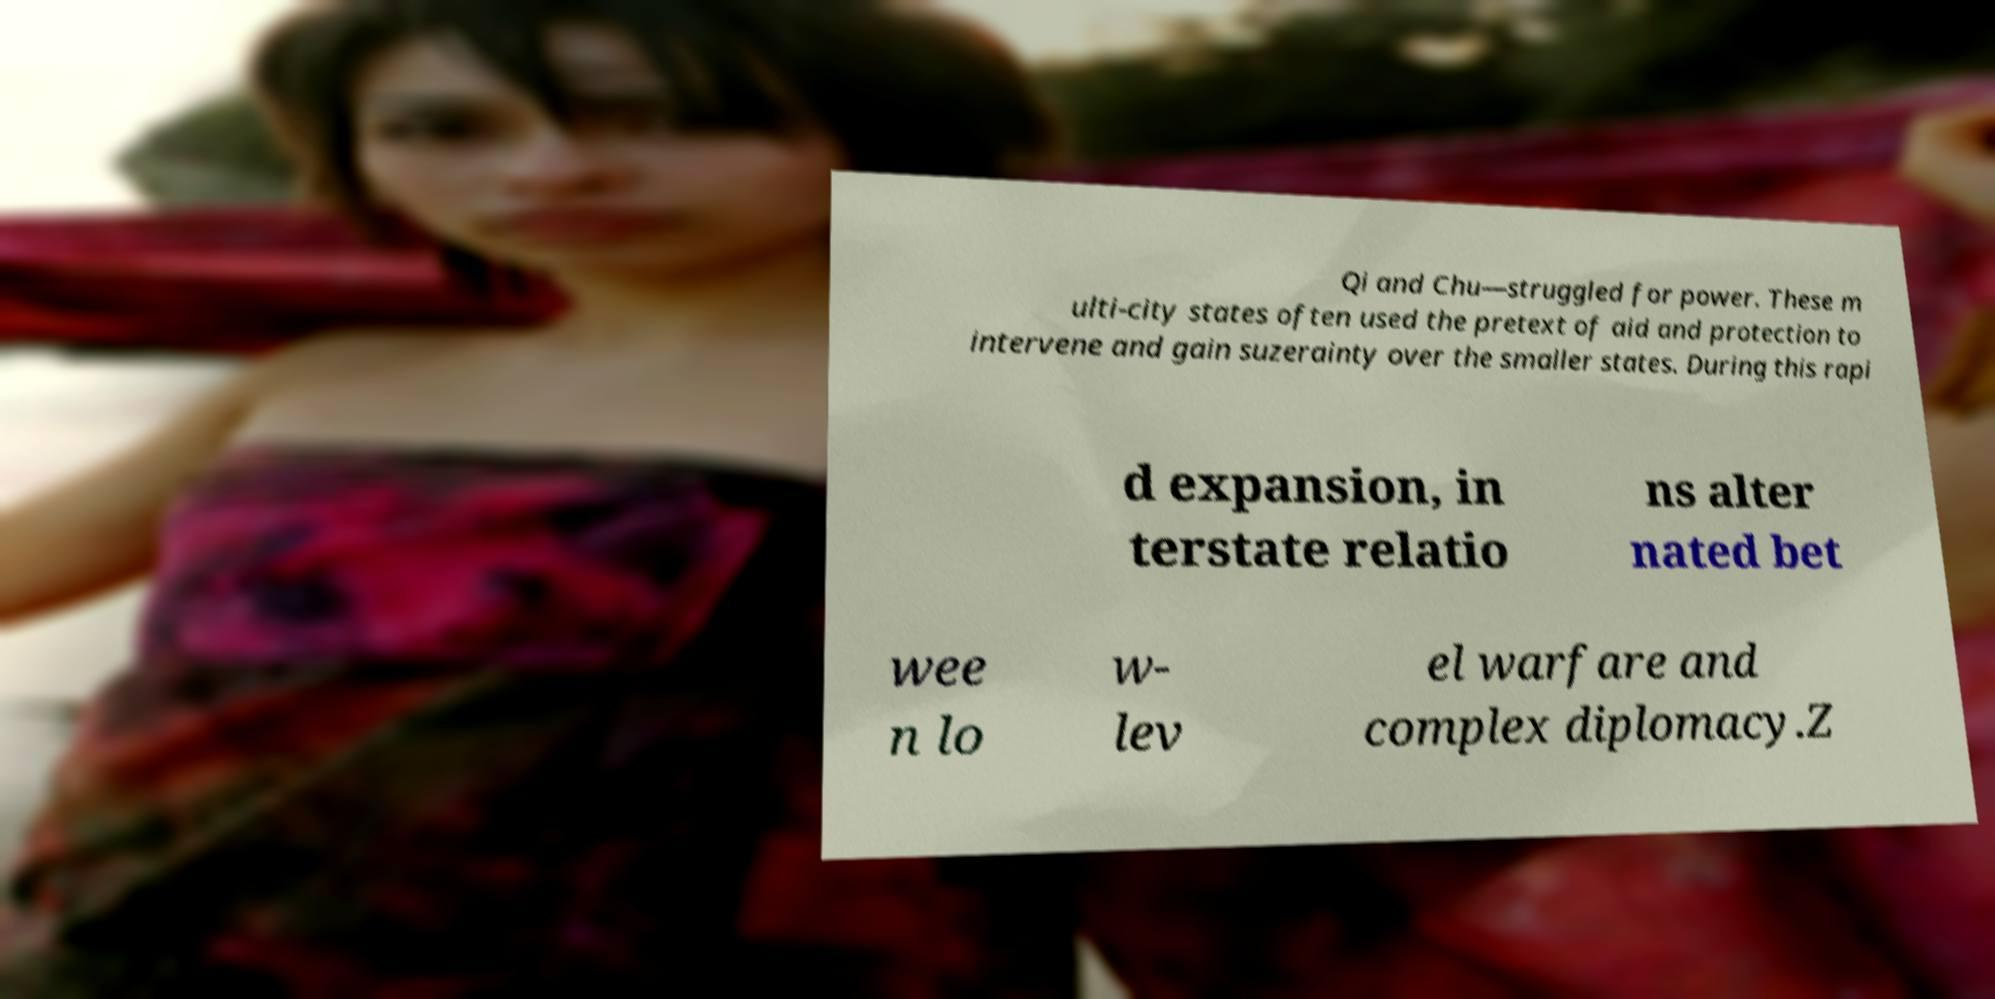Can you accurately transcribe the text from the provided image for me? Qi and Chu—struggled for power. These m ulti-city states often used the pretext of aid and protection to intervene and gain suzerainty over the smaller states. During this rapi d expansion, in terstate relatio ns alter nated bet wee n lo w- lev el warfare and complex diplomacy.Z 